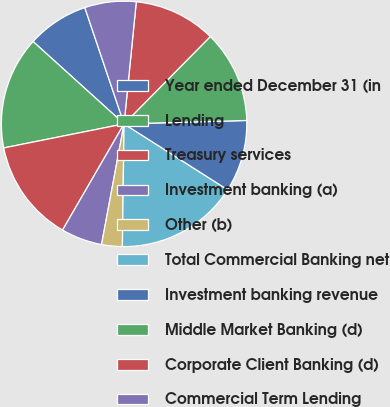Convert chart to OTSL. <chart><loc_0><loc_0><loc_500><loc_500><pie_chart><fcel>Year ended December 31 (in<fcel>Lending<fcel>Treasury services<fcel>Investment banking (a)<fcel>Other (b)<fcel>Total Commercial Banking net<fcel>Investment banking revenue<fcel>Middle Market Banking (d)<fcel>Corporate Client Banking (d)<fcel>Commercial Term Lending<nl><fcel>8.11%<fcel>14.85%<fcel>13.5%<fcel>5.42%<fcel>2.72%<fcel>16.2%<fcel>9.46%<fcel>12.16%<fcel>10.81%<fcel>6.77%<nl></chart> 